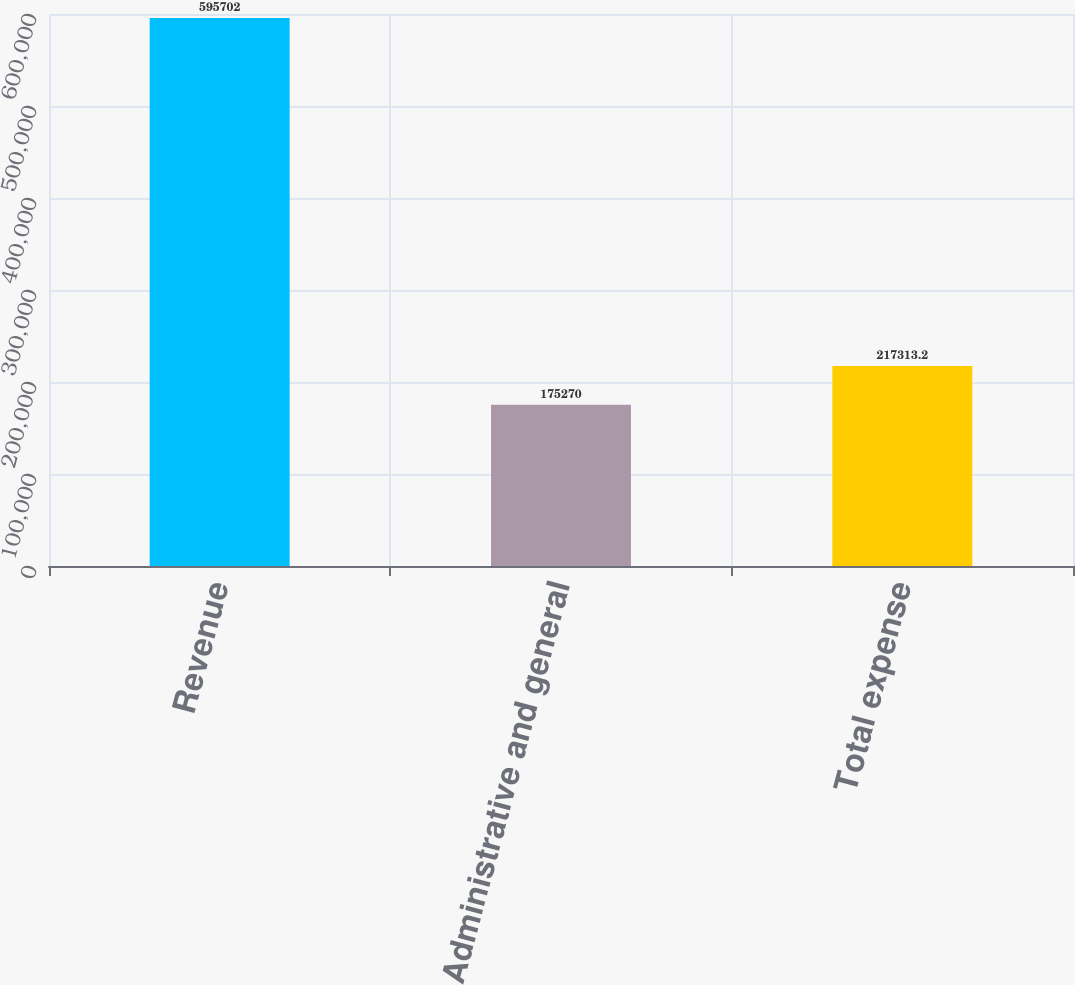<chart> <loc_0><loc_0><loc_500><loc_500><bar_chart><fcel>Revenue<fcel>Administrative and general<fcel>Total expense<nl><fcel>595702<fcel>175270<fcel>217313<nl></chart> 